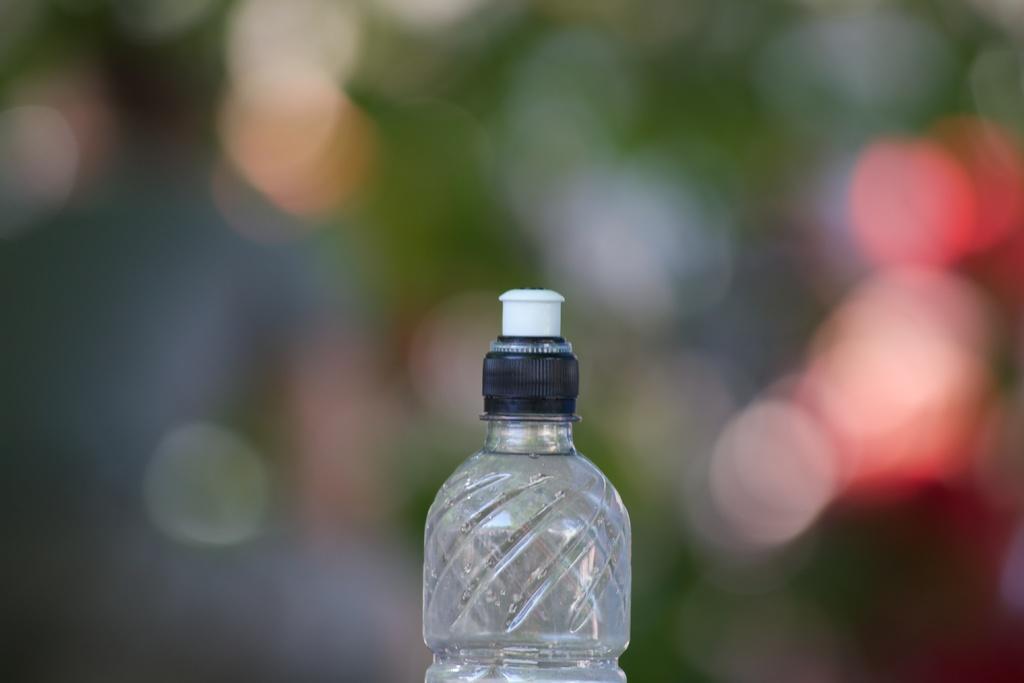How would you summarize this image in a sentence or two? In this picture we can see a bottle. 